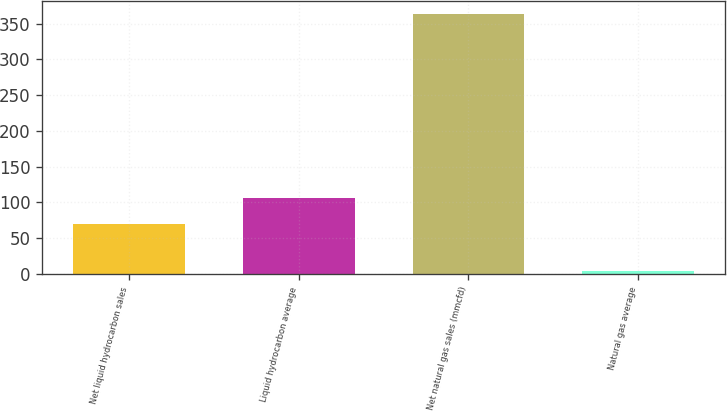Convert chart to OTSL. <chart><loc_0><loc_0><loc_500><loc_500><bar_chart><fcel>Net liquid hydrocarbon sales<fcel>Liquid hydrocarbon average<fcel>Net natural gas sales (mmcfd)<fcel>Natural gas average<nl><fcel>70<fcel>105.93<fcel>364<fcel>4.71<nl></chart> 